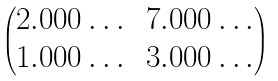<formula> <loc_0><loc_0><loc_500><loc_500>\begin{pmatrix} 2 . 0 0 0 \dots & 7 . 0 0 0 \dots \\ 1 . 0 0 0 \dots & 3 . 0 0 0 \dots \end{pmatrix}</formula> 